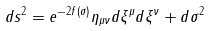Convert formula to latex. <formula><loc_0><loc_0><loc_500><loc_500>d s ^ { 2 } = e ^ { - 2 f ( \sigma ) } \eta _ { \mu \nu } d \xi ^ { \mu } d \xi ^ { \nu } + d \sigma ^ { 2 }</formula> 